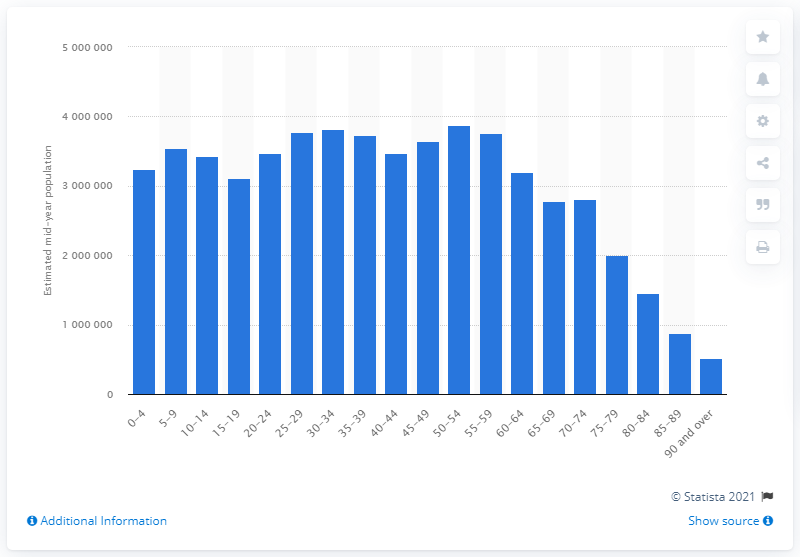Mention a couple of crucial points in this snapshot. In 2020, the lowest age group in England was individuals who were 90 years old or older. In 2020, it is estimated that there were approximately 387,535 people aged between 50 and 54 living in England. 